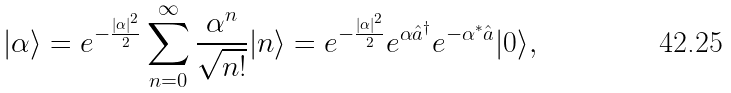<formula> <loc_0><loc_0><loc_500><loc_500>| \alpha \rangle = e ^ { - { \frac { | \alpha | ^ { 2 } } { 2 } } } \sum _ { n = 0 } ^ { \infty } { \frac { \alpha ^ { n } } { \sqrt { n ! } } } | n \rangle = e ^ { - { \frac { | \alpha | ^ { 2 } } { 2 } } } e ^ { \alpha { \hat { a } } ^ { \dagger } } e ^ { - { \alpha ^ { * } { \hat { a } } } } | 0 \rangle ,</formula> 